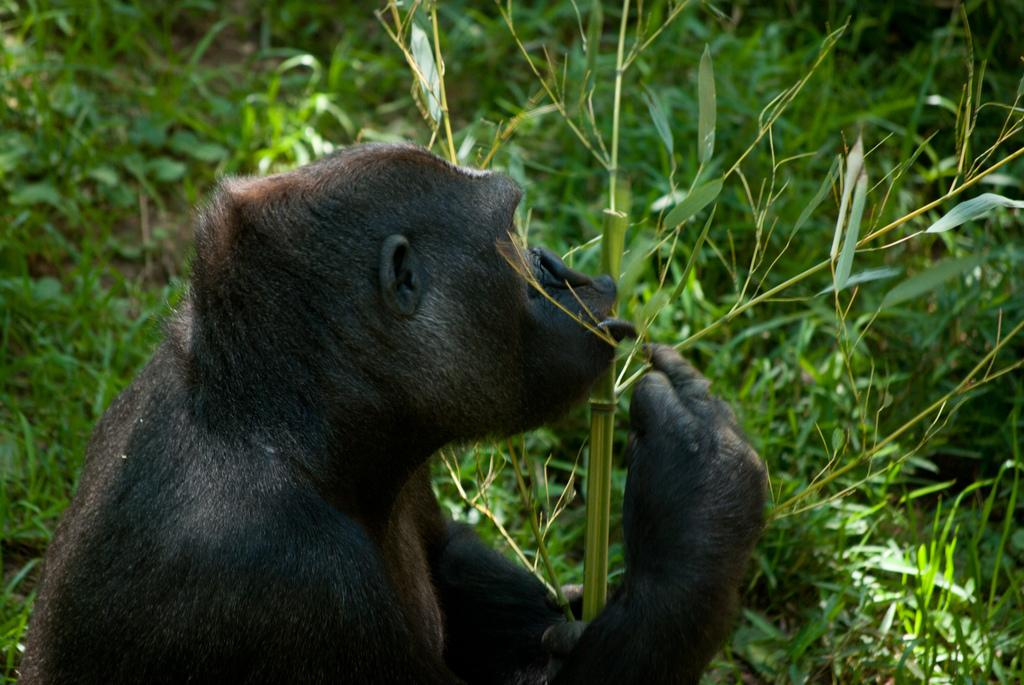What type of environment can be seen in the background of the image? There is greenery in the background of the image. What is the animal in the image doing? The animal is holding a stem in the image. What color are the leaves visible in the image? Green leaves are visible in the image. What else is green in the image besides the leaves? Green stems are present in the image. How does the animal use its grip to lock the stem in the image? The image does not show the animal using its grip to lock the stem, as it only depicts the animal holding the stem. 